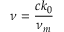<formula> <loc_0><loc_0><loc_500><loc_500>\nu = \frac { c k _ { 0 } } { \nu _ { m } }</formula> 